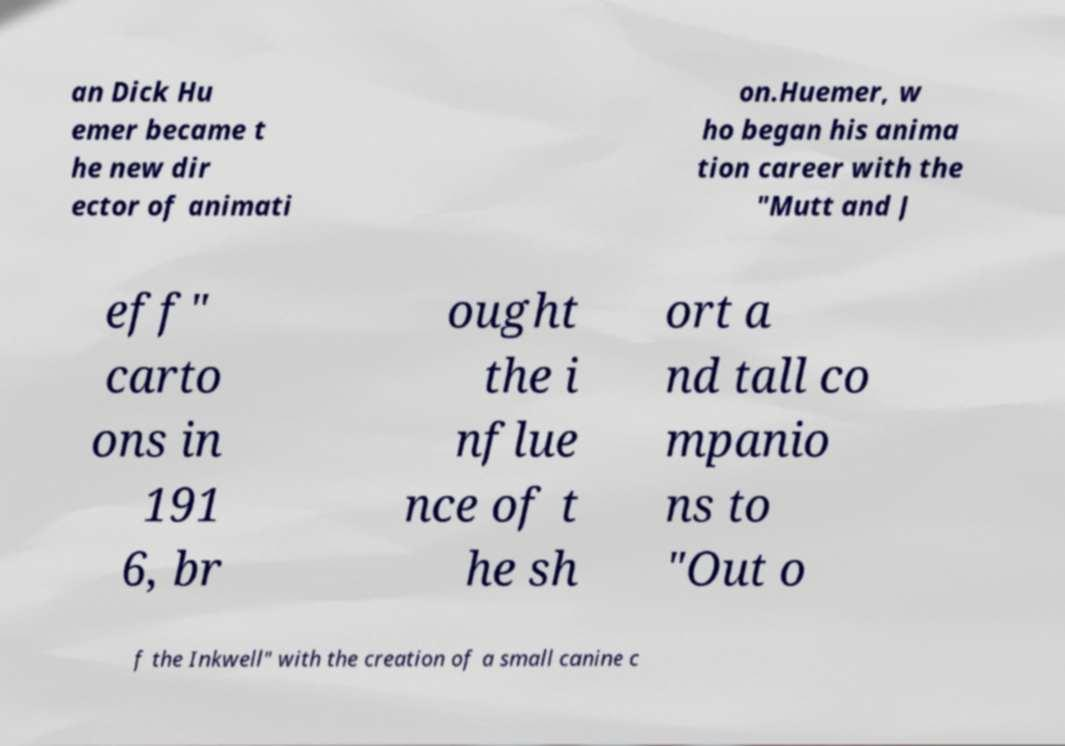Can you read and provide the text displayed in the image?This photo seems to have some interesting text. Can you extract and type it out for me? an Dick Hu emer became t he new dir ector of animati on.Huemer, w ho began his anima tion career with the "Mutt and J eff" carto ons in 191 6, br ought the i nflue nce of t he sh ort a nd tall co mpanio ns to "Out o f the Inkwell" with the creation of a small canine c 